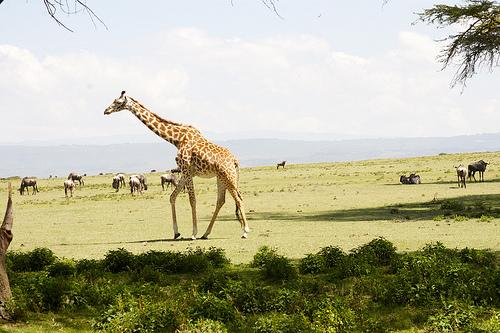What is the primary animal in the image, and what is its distinctive feature? The primary animal is a giraffe, which is identified by its long neck. Mention the types of vegetation and their colors in the image. There are green leaves on trees and small shrubs at the side of the field. Is there any element suggesting the possible environment habitation of the animals in the picture? Yes, it seems like the animals, including the giraffe, are in a field surrounded by trees and small shrubs. In the image, what are some objects or animals that can be seen in the sky or distant background? The sky has blue and white colors as well clouds, and there are small herd animals in the distant field. Estimate the time of day in the image based on the environmental features. It appears to be daytime, as there is sunlight and a white sky. What might the weather conditions be in the image based on visual clues? The weather is likely sunny and hazy, as the sky is white and blue in color with clouds. Describe the landscape in which the animals are found in this image. The animals are in a field with a small hill in the background and some small shrubs on the side. What is the overall tone or mood of the scene depicted in the image? The scene has a wild, natural environment with animals coexisting peacefully in a field during daytime. Mention any specific descriptive aspects describing the giraffe in the image. The giraffe has brown spots, two horns, short hairs on its back, and is white and brown in color. Can you see the pink elephant standing near the giraffe? No, it's not mentioned in the image. 